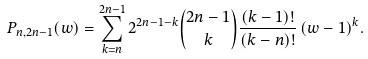Convert formula to latex. <formula><loc_0><loc_0><loc_500><loc_500>P _ { n , 2 n - 1 } ( w ) = \sum _ { k = n } ^ { 2 n - 1 } 2 ^ { 2 n - 1 - k } \binom { 2 n - 1 } { k } \frac { ( k - 1 ) ! } { ( k - n ) ! } \, ( w - 1 ) ^ { k } .</formula> 